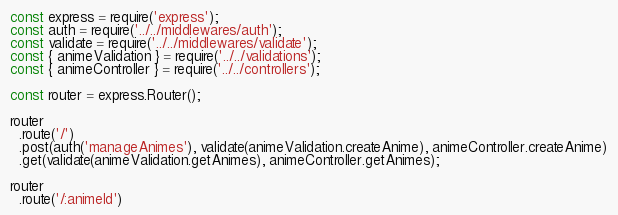Convert code to text. <code><loc_0><loc_0><loc_500><loc_500><_JavaScript_>const express = require('express');
const auth = require('../../middlewares/auth');
const validate = require('../../middlewares/validate');
const { animeValidation } = require('../../validations');
const { animeController } = require('../../controllers');

const router = express.Router();

router
  .route('/')
  .post(auth('manageAnimes'), validate(animeValidation.createAnime), animeController.createAnime)
  .get(validate(animeValidation.getAnimes), animeController.getAnimes);

router
  .route('/:animeId')</code> 